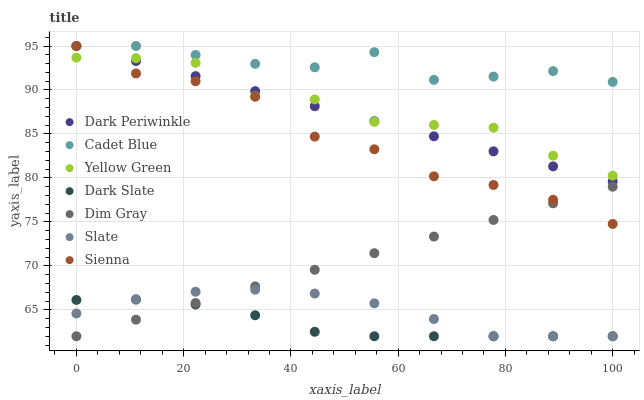Does Dark Slate have the minimum area under the curve?
Answer yes or no. Yes. Does Cadet Blue have the maximum area under the curve?
Answer yes or no. Yes. Does Yellow Green have the minimum area under the curve?
Answer yes or no. No. Does Yellow Green have the maximum area under the curve?
Answer yes or no. No. Is Dim Gray the smoothest?
Answer yes or no. Yes. Is Yellow Green the roughest?
Answer yes or no. Yes. Is Slate the smoothest?
Answer yes or no. No. Is Slate the roughest?
Answer yes or no. No. Does Dim Gray have the lowest value?
Answer yes or no. Yes. Does Yellow Green have the lowest value?
Answer yes or no. No. Does Dark Periwinkle have the highest value?
Answer yes or no. Yes. Does Yellow Green have the highest value?
Answer yes or no. No. Is Dim Gray less than Yellow Green?
Answer yes or no. Yes. Is Cadet Blue greater than Slate?
Answer yes or no. Yes. Does Yellow Green intersect Sienna?
Answer yes or no. Yes. Is Yellow Green less than Sienna?
Answer yes or no. No. Is Yellow Green greater than Sienna?
Answer yes or no. No. Does Dim Gray intersect Yellow Green?
Answer yes or no. No. 